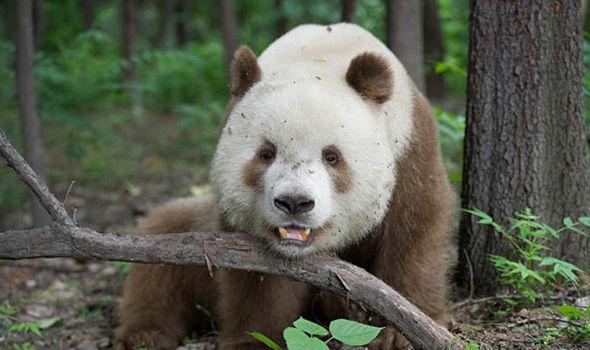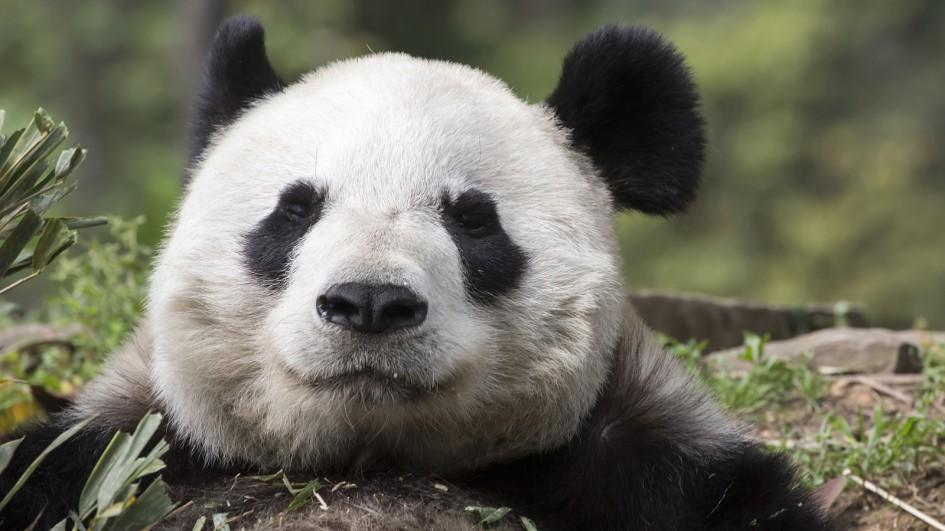The first image is the image on the left, the second image is the image on the right. Considering the images on both sides, is "the panda on the left image has its mouth open" valid? Answer yes or no. Yes. 